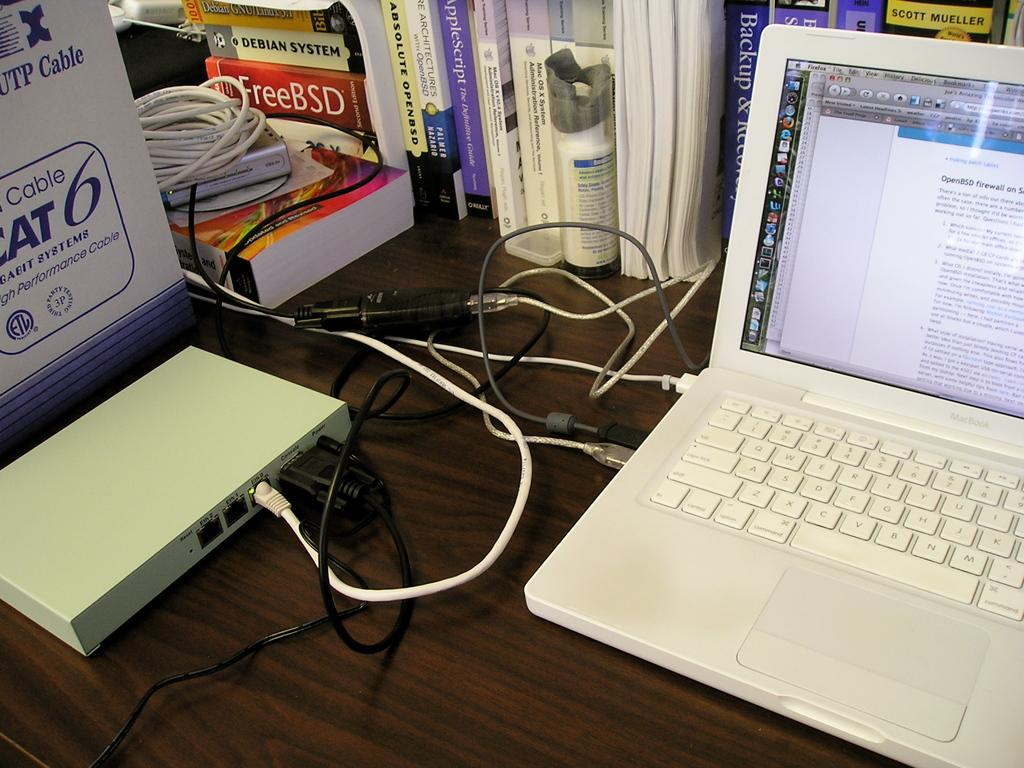<image>
Offer a succinct explanation of the picture presented. a white laptop is connected to wires near a sign for Cable Cat 6 